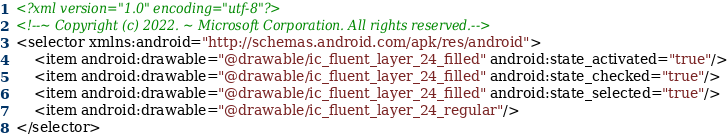<code> <loc_0><loc_0><loc_500><loc_500><_XML_><?xml version="1.0" encoding="utf-8"?>
<!--~ Copyright (c) 2022. ~ Microsoft Corporation. All rights reserved.-->
<selector xmlns:android="http://schemas.android.com/apk/res/android">
    <item android:drawable="@drawable/ic_fluent_layer_24_filled" android:state_activated="true"/>
    <item android:drawable="@drawable/ic_fluent_layer_24_filled" android:state_checked="true"/>
    <item android:drawable="@drawable/ic_fluent_layer_24_filled" android:state_selected="true"/>
    <item android:drawable="@drawable/ic_fluent_layer_24_regular"/>
</selector>
</code> 